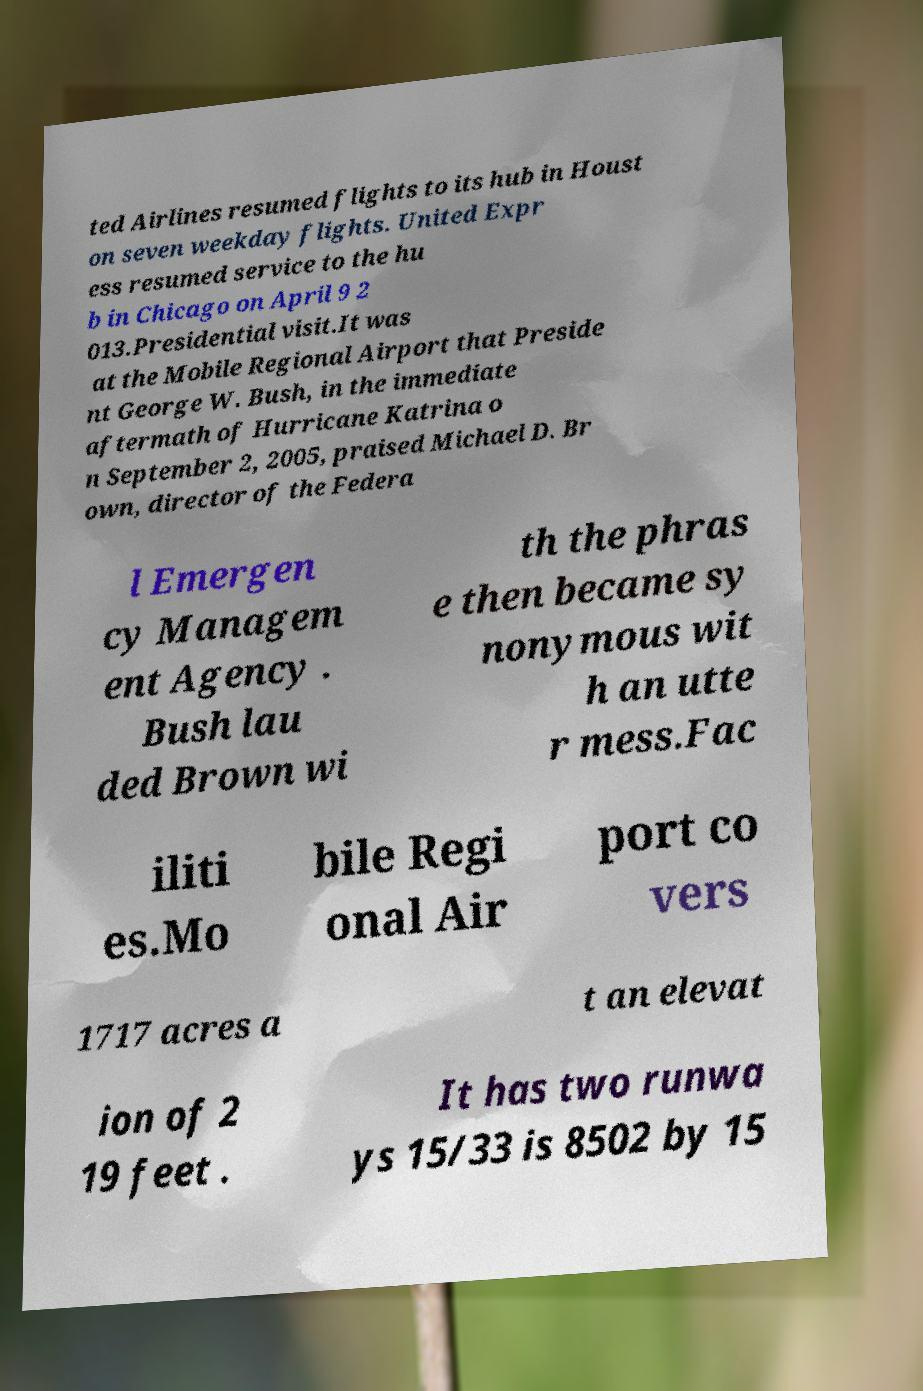There's text embedded in this image that I need extracted. Can you transcribe it verbatim? ted Airlines resumed flights to its hub in Houst on seven weekday flights. United Expr ess resumed service to the hu b in Chicago on April 9 2 013.Presidential visit.It was at the Mobile Regional Airport that Preside nt George W. Bush, in the immediate aftermath of Hurricane Katrina o n September 2, 2005, praised Michael D. Br own, director of the Federa l Emergen cy Managem ent Agency . Bush lau ded Brown wi th the phras e then became sy nonymous wit h an utte r mess.Fac iliti es.Mo bile Regi onal Air port co vers 1717 acres a t an elevat ion of 2 19 feet . It has two runwa ys 15/33 is 8502 by 15 